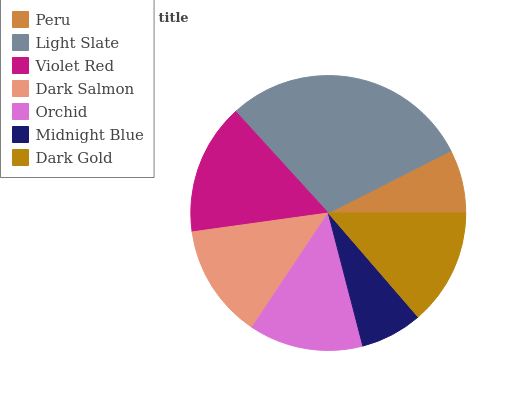Is Midnight Blue the minimum?
Answer yes or no. Yes. Is Light Slate the maximum?
Answer yes or no. Yes. Is Violet Red the minimum?
Answer yes or no. No. Is Violet Red the maximum?
Answer yes or no. No. Is Light Slate greater than Violet Red?
Answer yes or no. Yes. Is Violet Red less than Light Slate?
Answer yes or no. Yes. Is Violet Red greater than Light Slate?
Answer yes or no. No. Is Light Slate less than Violet Red?
Answer yes or no. No. Is Dark Salmon the high median?
Answer yes or no. Yes. Is Dark Salmon the low median?
Answer yes or no. Yes. Is Dark Gold the high median?
Answer yes or no. No. Is Peru the low median?
Answer yes or no. No. 